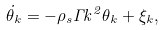Convert formula to latex. <formula><loc_0><loc_0><loc_500><loc_500>\dot { \theta } _ { k } = - \rho _ { s } \Gamma k ^ { 2 } \theta _ { k } + \xi _ { k } ,</formula> 